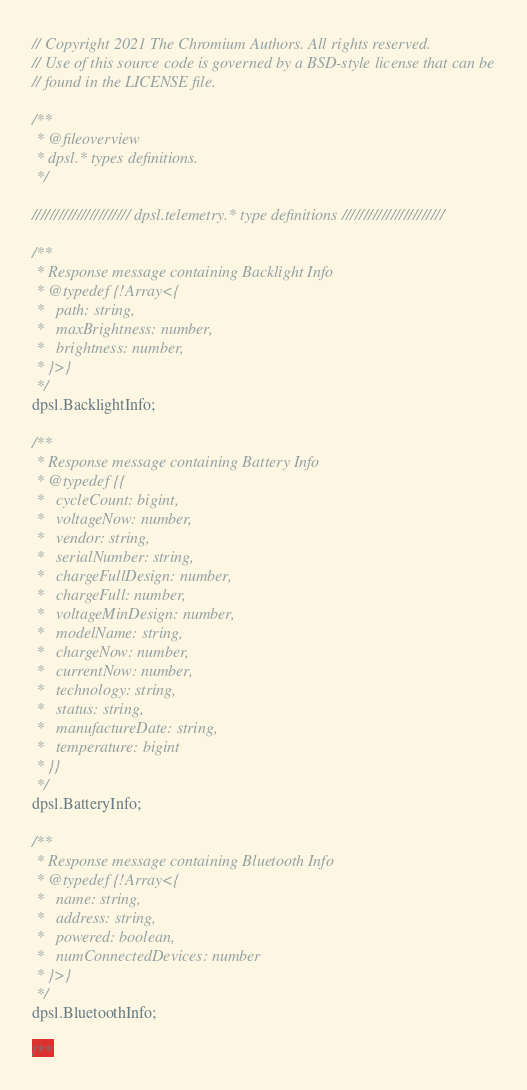Convert code to text. <code><loc_0><loc_0><loc_500><loc_500><_JavaScript_>// Copyright 2021 The Chromium Authors. All rights reserved.
// Use of this source code is governed by a BSD-style license that can be
// found in the LICENSE file.

/**
 * @fileoverview
 * dpsl.* types definitions.
 */

////////////////////// dpsl.telemetry.* type definitions ///////////////////////

/**
 * Response message containing Backlight Info
 * @typedef {!Array<{
 *   path: string,
 *   maxBrightness: number,
 *   brightness: number,
 * }>}
 */
dpsl.BacklightInfo;

/**
 * Response message containing Battery Info
 * @typedef {{
 *   cycleCount: bigint,
 *   voltageNow: number,
 *   vendor: string,
 *   serialNumber: string,
 *   chargeFullDesign: number,
 *   chargeFull: number,
 *   voltageMinDesign: number,
 *   modelName: string,
 *   chargeNow: number,
 *   currentNow: number,
 *   technology: string,
 *   status: string,
 *   manufactureDate: string,
 *   temperature: bigint
 * }}
 */
dpsl.BatteryInfo;

/**
 * Response message containing Bluetooth Info
 * @typedef {!Array<{
 *   name: string,
 *   address: string,
 *   powered: boolean,
 *   numConnectedDevices: number
 * }>}
 */
dpsl.BluetoothInfo;

/**</code> 